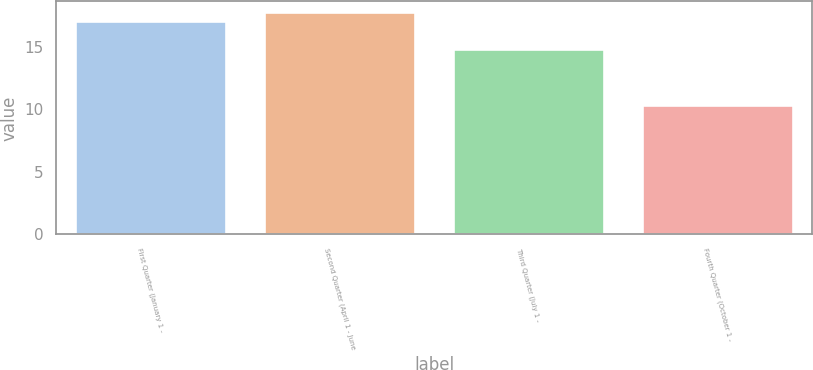Convert chart to OTSL. <chart><loc_0><loc_0><loc_500><loc_500><bar_chart><fcel>First Quarter (January 1 -<fcel>Second Quarter (April 1 - June<fcel>Third Quarter (July 1 -<fcel>Fourth Quarter (October 1 -<nl><fcel>17.05<fcel>17.73<fcel>14.8<fcel>10.36<nl></chart> 